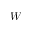<formula> <loc_0><loc_0><loc_500><loc_500>W</formula> 